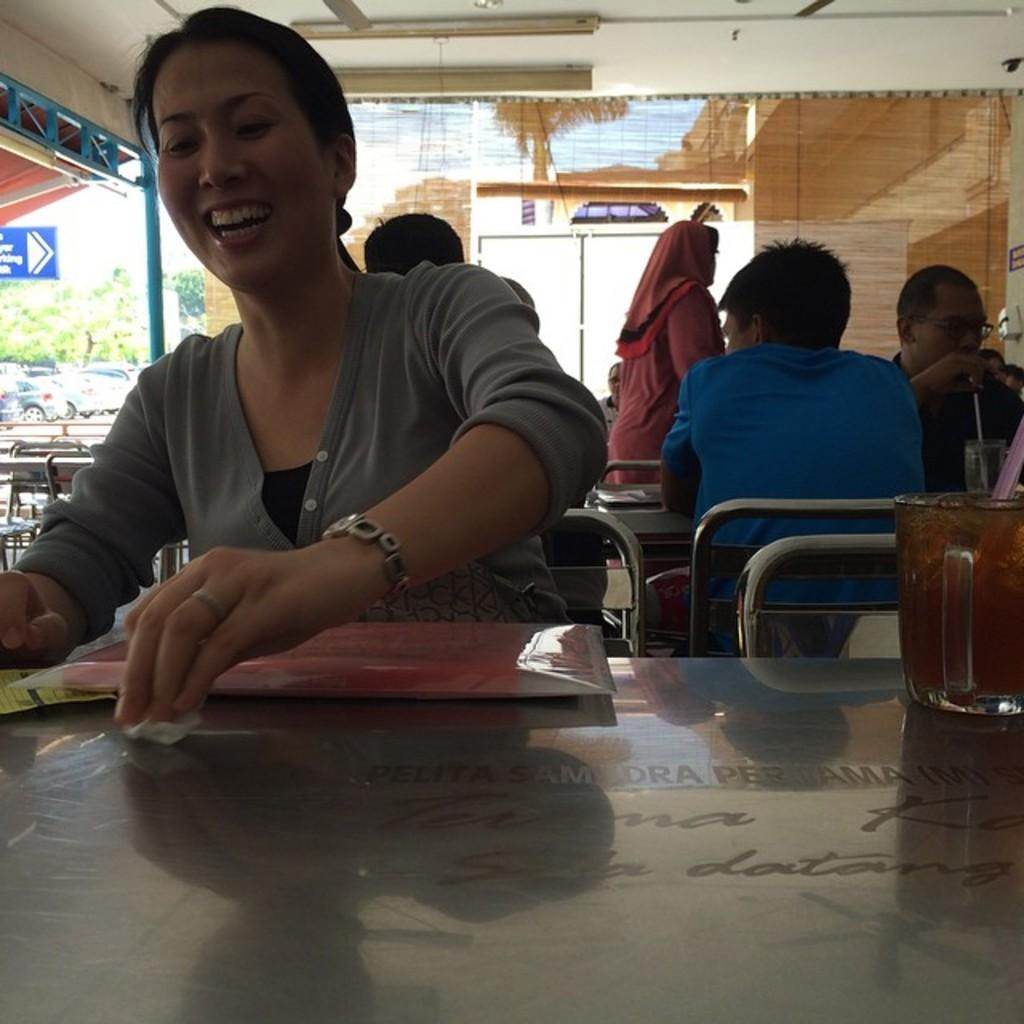What are the people in the image doing? The people in the image are sitting on chairs. What is present in the image besides the people? There is a table in the image. What can be seen on the table? There is a juice glass on the table in the image. Are there any horses or yokes present in the image? No, there are no horses or yokes present in the image. What type of pets can be seen in the image? There are no pets visible in the image. 